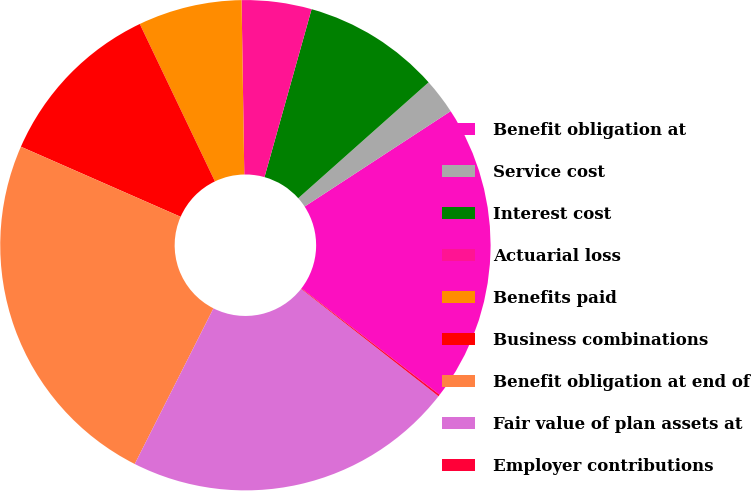Convert chart to OTSL. <chart><loc_0><loc_0><loc_500><loc_500><pie_chart><fcel>Benefit obligation at<fcel>Service cost<fcel>Interest cost<fcel>Actuarial loss<fcel>Benefits paid<fcel>Business combinations<fcel>Benefit obligation at end of<fcel>Fair value of plan assets at<fcel>Employer contributions<nl><fcel>19.65%<fcel>2.36%<fcel>9.08%<fcel>4.6%<fcel>6.84%<fcel>11.33%<fcel>24.13%<fcel>21.89%<fcel>0.12%<nl></chart> 